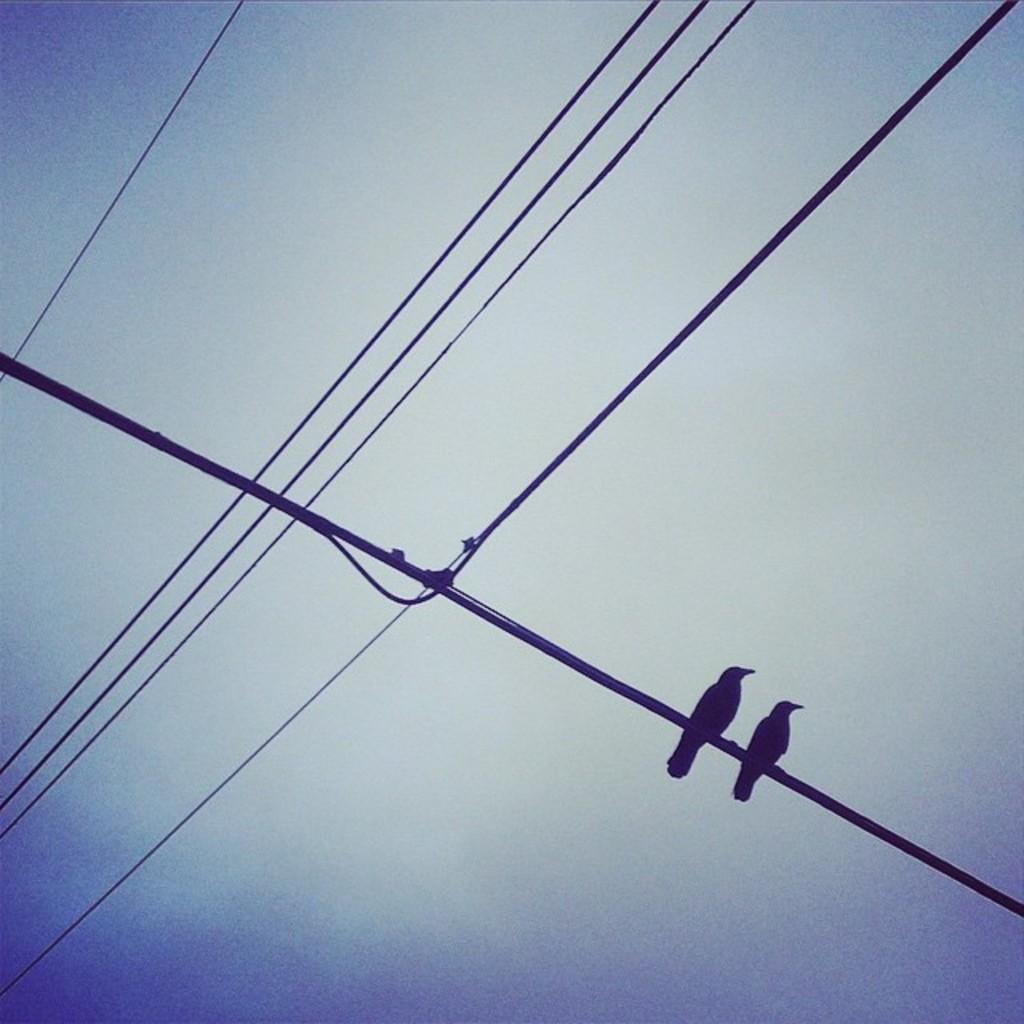Can you describe this image briefly? In this picture we can see wires and two birds on a wire and in the background we can see the sky. 